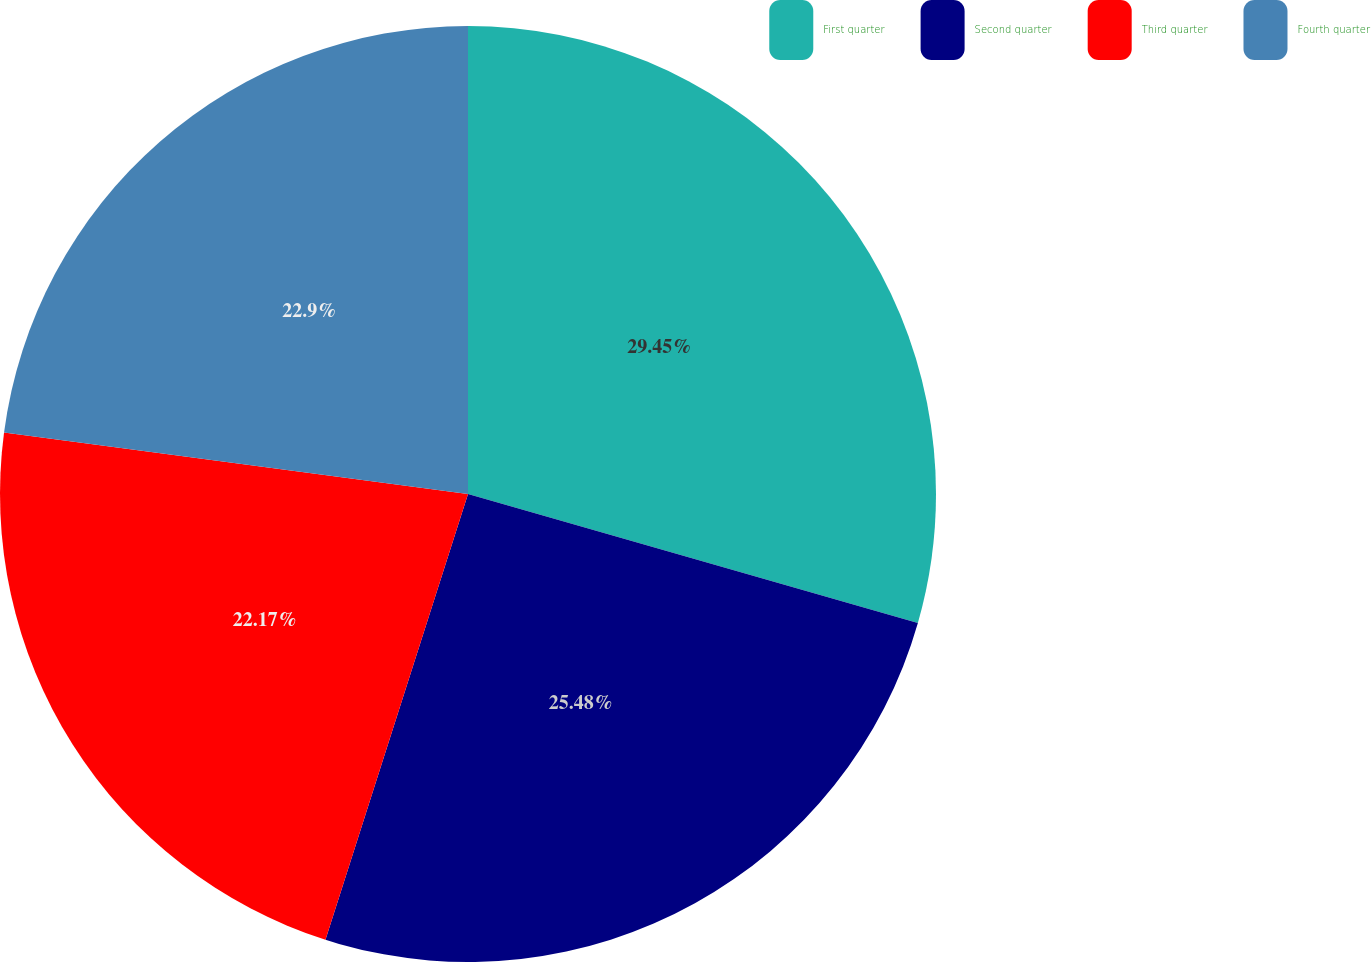<chart> <loc_0><loc_0><loc_500><loc_500><pie_chart><fcel>First quarter<fcel>Second quarter<fcel>Third quarter<fcel>Fourth quarter<nl><fcel>29.44%<fcel>25.48%<fcel>22.17%<fcel>22.9%<nl></chart> 